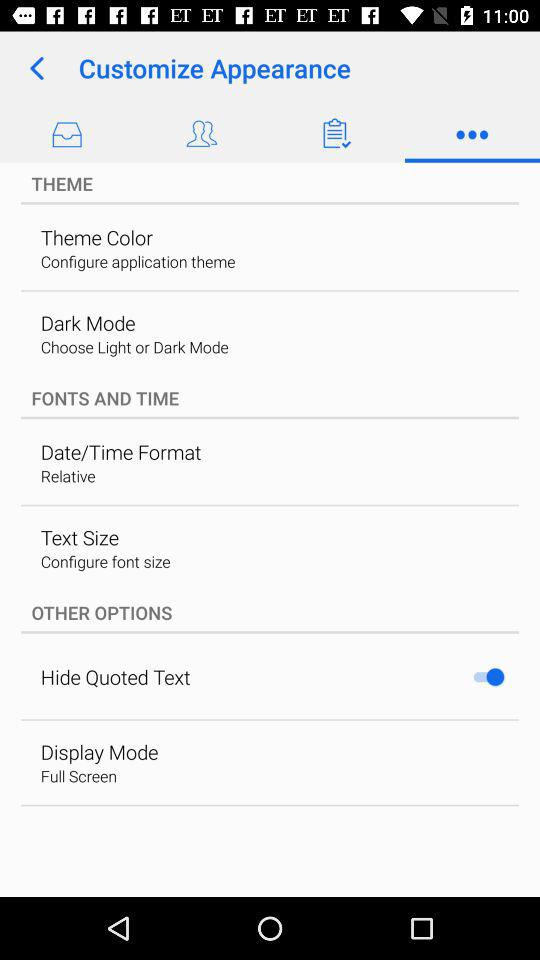Which display mode is chosen? The chosen display mode is "Full Screen". 